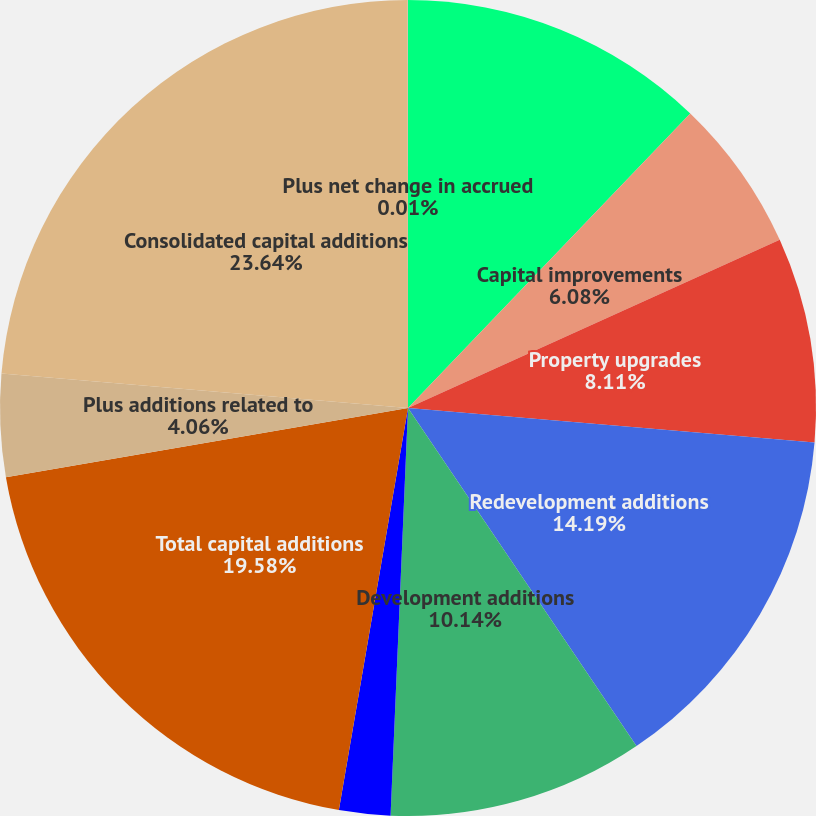Convert chart. <chart><loc_0><loc_0><loc_500><loc_500><pie_chart><fcel>Capital replacements<fcel>Capital improvements<fcel>Property upgrades<fcel>Redevelopment additions<fcel>Development additions<fcel>Casualty replacements<fcel>Total capital additions<fcel>Plus additions related to<fcel>Consolidated capital additions<fcel>Plus net change in accrued<nl><fcel>12.16%<fcel>6.08%<fcel>8.11%<fcel>14.19%<fcel>10.14%<fcel>2.03%<fcel>19.58%<fcel>4.06%<fcel>23.64%<fcel>0.01%<nl></chart> 